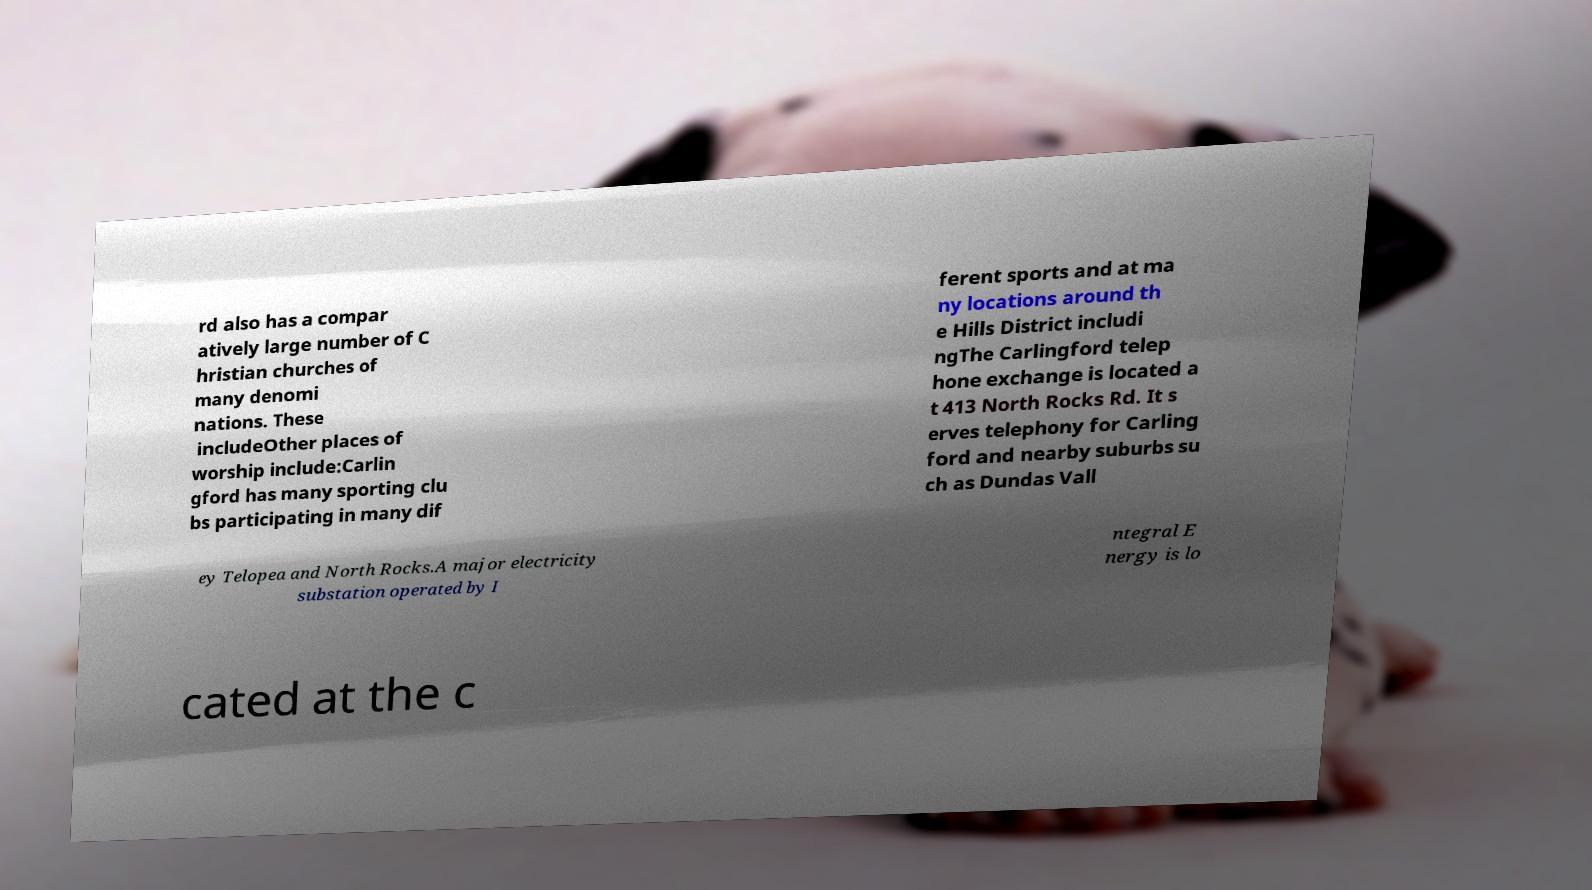Can you read and provide the text displayed in the image?This photo seems to have some interesting text. Can you extract and type it out for me? rd also has a compar atively large number of C hristian churches of many denomi nations. These includeOther places of worship include:Carlin gford has many sporting clu bs participating in many dif ferent sports and at ma ny locations around th e Hills District includi ngThe Carlingford telep hone exchange is located a t 413 North Rocks Rd. It s erves telephony for Carling ford and nearby suburbs su ch as Dundas Vall ey Telopea and North Rocks.A major electricity substation operated by I ntegral E nergy is lo cated at the c 